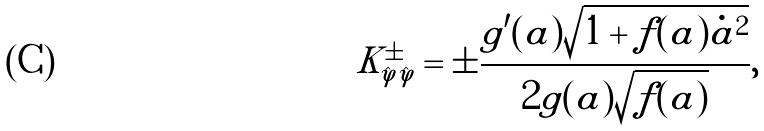Convert formula to latex. <formula><loc_0><loc_0><loc_500><loc_500>K _ { \hat { \varphi } \hat { \varphi } } ^ { \pm } = \pm \frac { g ^ { \prime } ( a ) \sqrt { 1 + f ( a ) \dot { a } ^ { 2 } } } { 2 g ( a ) \sqrt { f ( a ) } } ,</formula> 